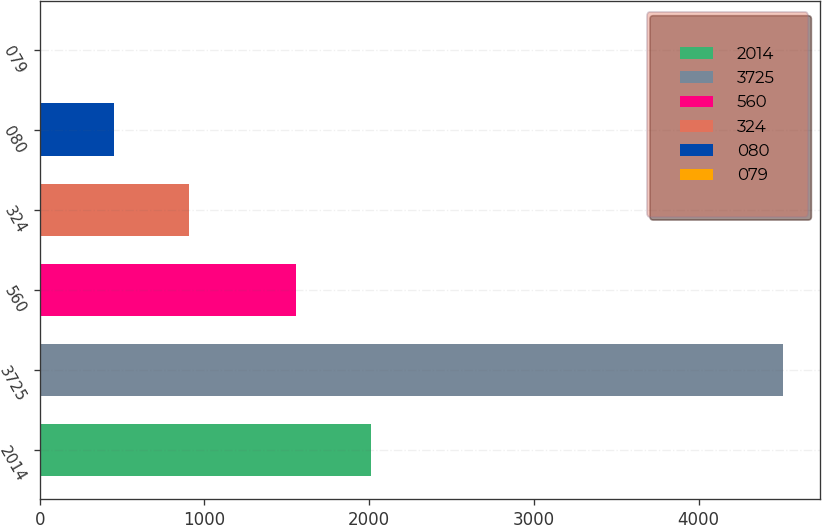<chart> <loc_0><loc_0><loc_500><loc_500><bar_chart><fcel>2014<fcel>3725<fcel>560<fcel>324<fcel>080<fcel>079<nl><fcel>2014<fcel>4510<fcel>1554<fcel>903.32<fcel>452.48<fcel>1.64<nl></chart> 